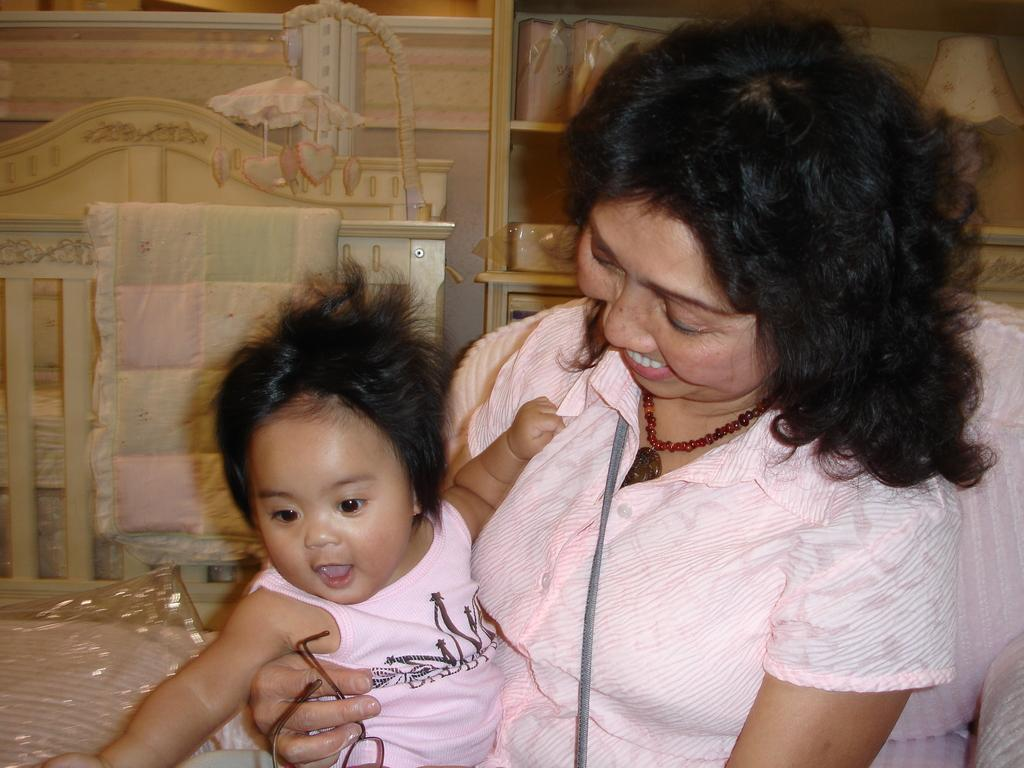Who is in the image? There is a woman in the image. What is the woman doing? The woman is smiling and holding a baby. Can you describe the lighting in the image? There is a light visible in the image. What can be seen in the background of the image? There are things in the racks in the background of the image. What is the value of the snow in the image? There is no snow present in the image, so it is not possible to determine its value. 